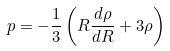<formula> <loc_0><loc_0><loc_500><loc_500>p = - \frac { 1 } { 3 } \left ( R \frac { d \rho } { d R } + 3 \rho \right )</formula> 